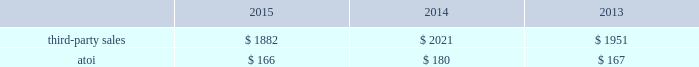Third-party sales for this segment increased 4% ( 4 % ) in 2014 compared with 2013 , primarily due to higher volumes and the acquisition of firth rixson ( $ 81 2014see above ) .
The higher volumes were mostly related to the aerospace ( commercial ) and commercial transportation end markets , somewhat offset by lower volumes in the industrial gas turbine end market .
Atoi for the engineered products and solutions segment increased $ 16 in 2015 compared with 2014 , principally the result of net productivity improvements across most businesses , a positive contribution from inorganic growth , and overall higher volumes in this segment 2019s organic businesses .
These positive impacts were partially offset by unfavorable price/product mix , higher costs related to growth projects , and net unfavorable foreign currency movements , primarily related to a weaker euro .
Atoi for this segment climbed $ 10 in 2014 compared with 2013 , mainly due to net productivity improvements across all businesses and overall higher volumes , partially offset by higher costs , primarily labor , and unfavorable product in 2016 , demand in the commercial aerospace end market is expected to remain strong , driven by significant order backlog .
Also , third-party sales will include a positive impact due to a full year of sales related to the acquisitions of rti and tital .
Additionally , net productivity improvements are anticipated while pricing pressure across all markets is expected .
Transportation and construction solutions .
This segment represents a portion of alcoa 2019s downstream operations and produces products that are used mostly in the nonresidential building and construction and commercial transportation end markets .
Such products include integrated aluminum structural systems , architectural extrusions , and forged aluminum commercial vehicle wheels , which are sold directly to customers and through distributors .
A small part of this segment also produces aluminum products for the industrial products end market .
Generally , the sales and costs and expenses of this segment are transacted in the local currency of the respective operations , which are mostly the u.s .
Dollar , the euro , and the brazilian real .
Third-party sales for the transportation and construction solutions segment decreased 7% ( 7 % ) in 2015 compared with 2014 , primarily driven by unfavorable foreign currency movements , principally caused by a weaker euro and brazilian real , and lower volume related to the building and construction end market , somewhat offset by higher volume related to the commercial transportation end market .
Third-party sales for this segment increased 4% ( 4 % ) in 2014 compared with 2013 , mostly the result of higher volume related to the commercial transportation and building and construction end markets , somewhat offset by lower volume in the industrial products and market .
Atoi for the transportation and construction solutions segment declined $ 14 in 2015 compared with 2014 , mainly due to higher costs , net unfavorable foreign currency movements , primarily related to a weaker euro and brazilian real , and unfavorable price/product mix .
These negative impacts were mostly offset by net productivity improvements across all businesses .
Atoi for this segment improved $ 13 in 2014 compared with 2013 , principally attributable to net productivity improvements across all businesses and overall higher volumes , partially offset by unfavorable product mix and higher costs , primarily labor .
In 2016 , the non-residential building and construction end market is expected to improve through growth in north america but will be slightly offset by overall weakness in europe .
Also , north america build rates in the commercial .
What is the percentual contribution of the acquisition of firth rixson in the third-party sales in 2014? 
Rationale: it is the value of the acquisition of firth rixson divided by the total third-party sales .
Computations: (81 / 2021)
Answer: 0.04008. 